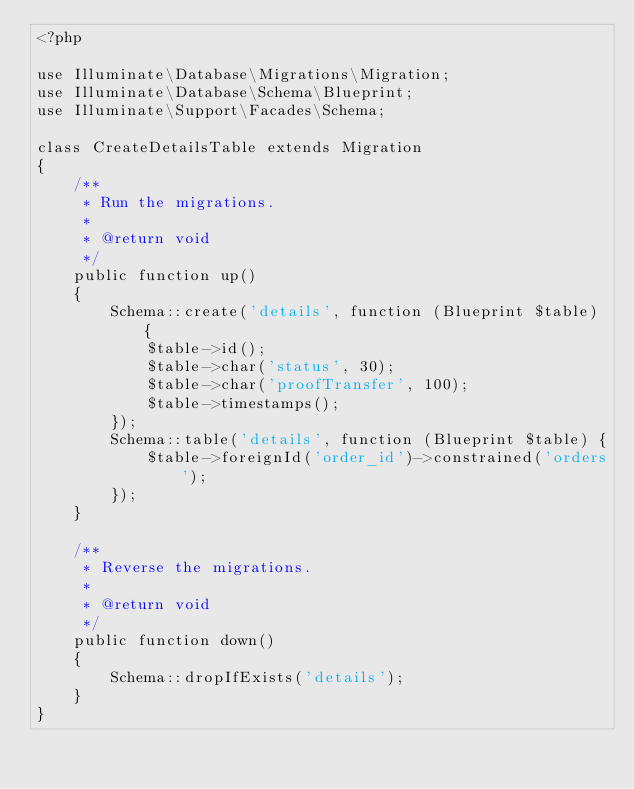<code> <loc_0><loc_0><loc_500><loc_500><_PHP_><?php

use Illuminate\Database\Migrations\Migration;
use Illuminate\Database\Schema\Blueprint;
use Illuminate\Support\Facades\Schema;

class CreateDetailsTable extends Migration
{
    /**
     * Run the migrations.
     *
     * @return void
     */
    public function up()
    {
        Schema::create('details', function (Blueprint $table) {
            $table->id();
            $table->char('status', 30);
            $table->char('proofTransfer', 100);
            $table->timestamps();
        });
        Schema::table('details', function (Blueprint $table) {
            $table->foreignId('order_id')->constrained('orders');
        });
    }

    /**
     * Reverse the migrations.
     *
     * @return void
     */
    public function down()
    {
        Schema::dropIfExists('details');
    }
}</code> 